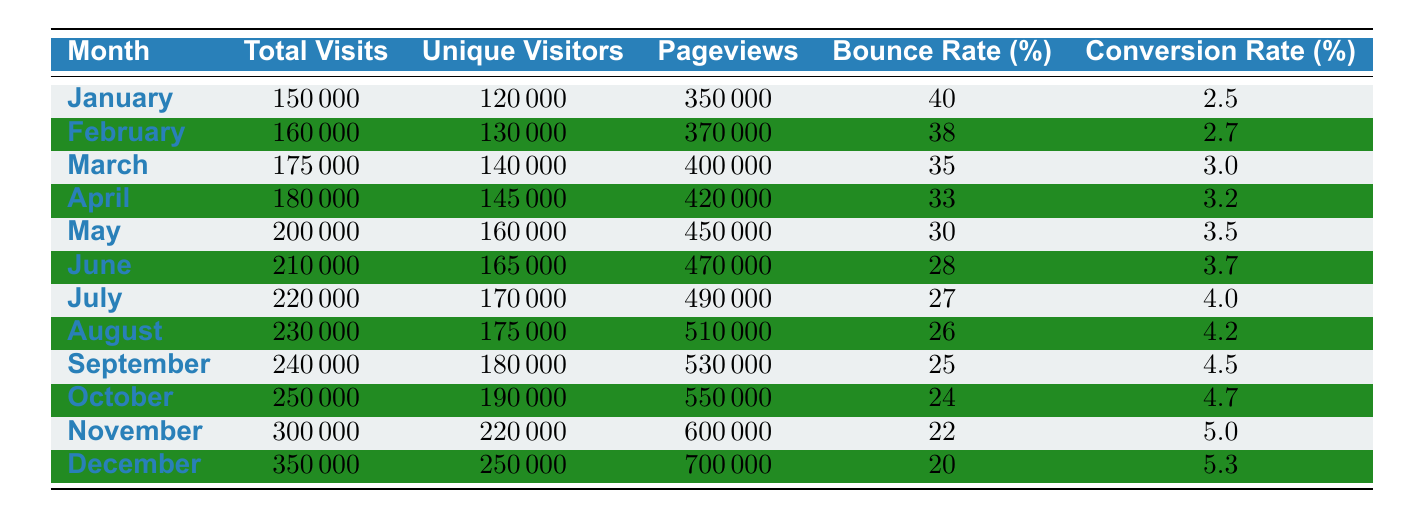What is the total number of unique visitors in November? In the table, the entry for November shows a value of 220,000 under the "Unique Visitors" column.
Answer: 220,000 Which month had the highest total visits? By examining the "Total Visits" column, December with 350,000 visits is the highest compared to all other months.
Answer: December What is the conversion rate for March? The table lists the conversion rate for March at 3.0% in the "Conversion Rate" column.
Answer: 3.0% What is the average bounce rate for the first half of the year? To find the average bounce rate from January to June, we sum the bounce rates of those months (40 + 38 + 35 + 33 + 30 + 28 = 234) and divide by 6, which gives us 234 / 6 = 39.
Answer: 39% In which month did the conversion rate exceed 4% for the first time? By checking the "Conversion Rate" column, we can see that the conversion rate first exceeds 4% in July, which has a value of 4.0%.
Answer: July What is the difference in total visits between January and December? We subtract the total visits in January (150,000) from those in December (350,000), thus 350,000 - 150,000 = 200,000.
Answer: 200,000 Did the bounce rate decrease every month from January to December? Looking at the "Bounce Rate" column, we see a consistent decrease each month from January (40%) down to December (20%). Therefore, the statement is true.
Answer: Yes Which month had the most significant increase in unique visitors compared to the previous month? Comparing the unique visitors month-to-month, we notice the largest increase is from October (190,000) to November (220,000), which is a difference of 30,000.
Answer: November What is the sum of total visits for the last quarter (October to December)? By summing the total visits of October (250,000), November (300,000), and December (350,000), we find that 250,000 + 300,000 + 350,000 = 900,000.
Answer: 900,000 What was the unique visitor count in August compared to June? In August the unique visitors count is 175,000, and in June it is 165,000, showing an increase of 10,000 from June to August.
Answer: Increase of 10,000 What was the trend of pageviews from January to December? We observe the pageviews: January (350,000), February (370,000), March (400,000), April (420,000), May (450,000), June (470,000), July (490,000), August (510,000), September (530,000), October (550,000), November (600,000), and December (700,000). This indicates a steady increasing trend throughout the year.
Answer: Increasing trend 